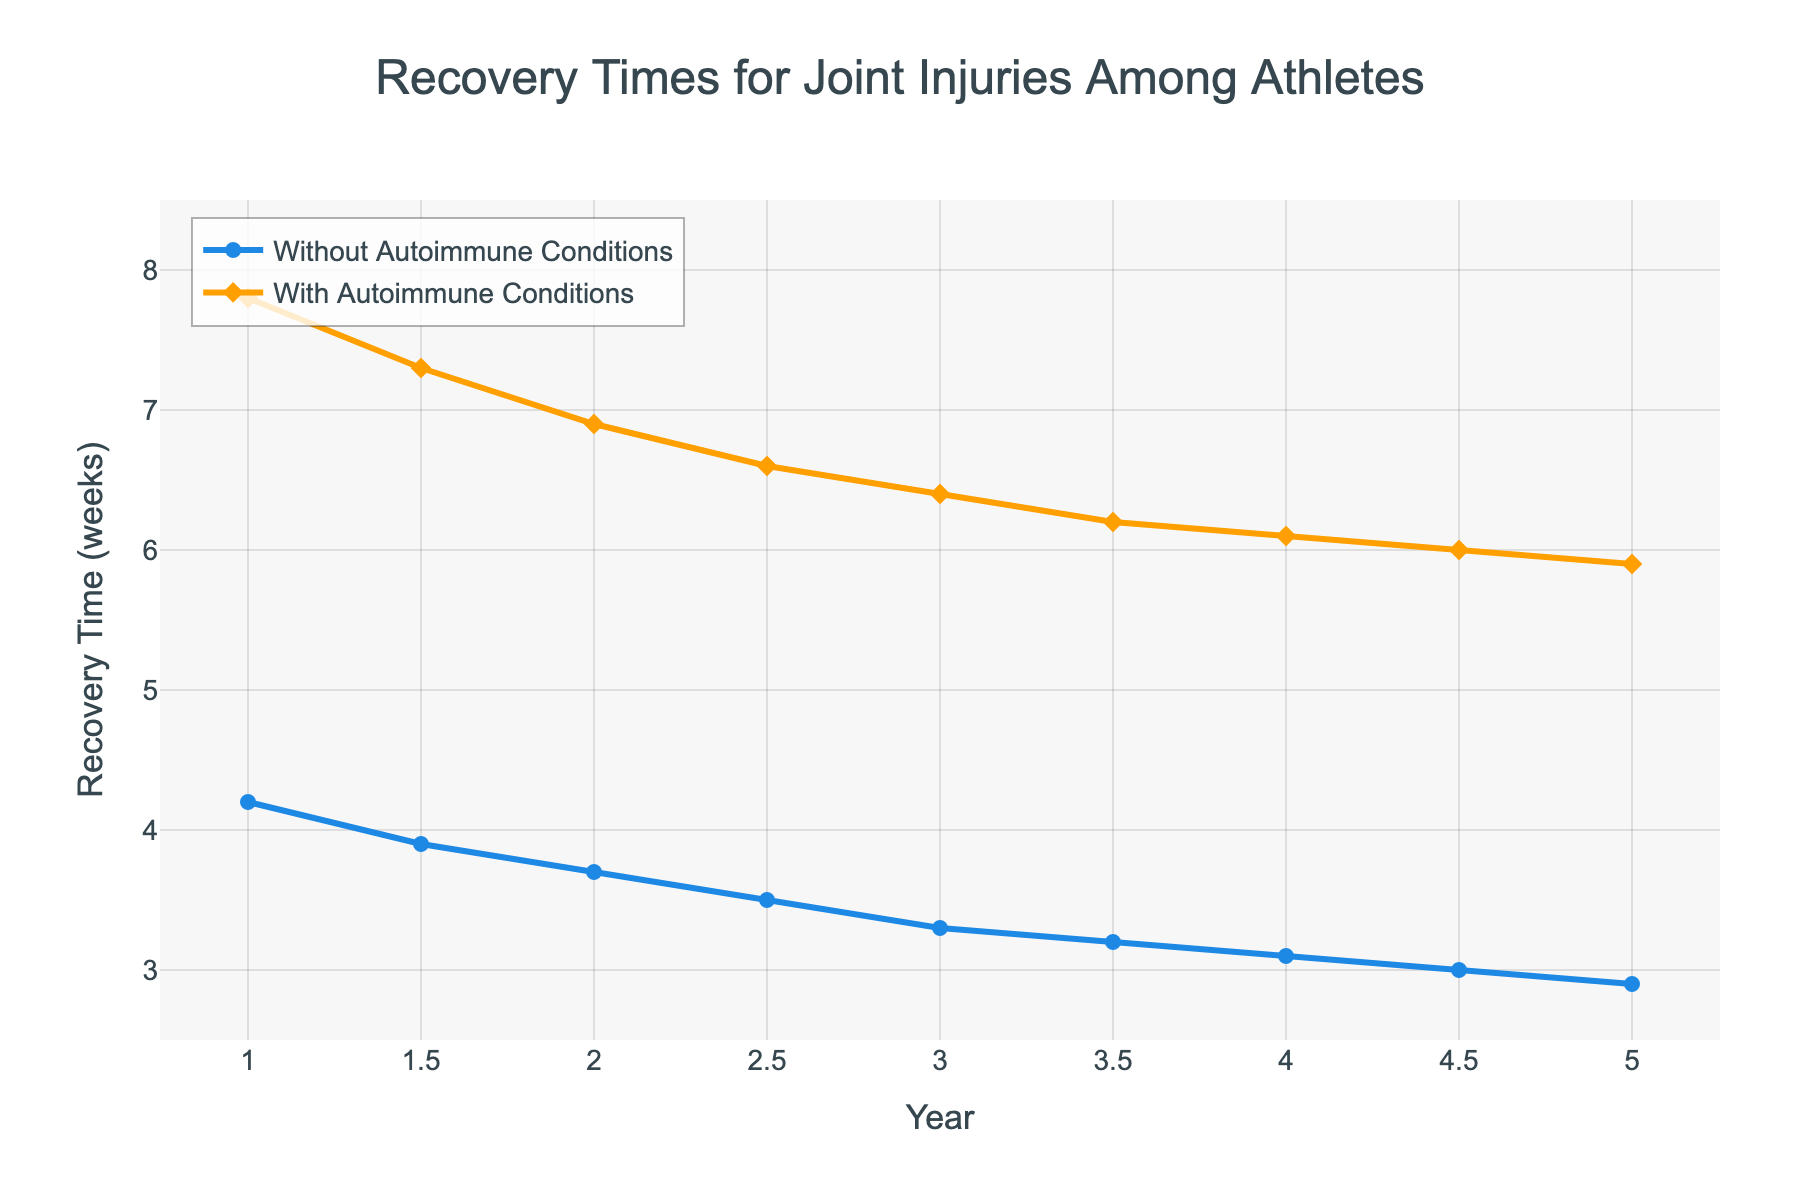What is the trend in recovery times over the 5-year period for athletes without autoimmune conditions? To identify the trend for athletes without autoimmune conditions, follow the blue line in the figure. Over the 5-year period, the recovery time decreases gradually from 4.2 weeks to 2.9 weeks.
Answer: Decreasing What is the difference in recovery times between the two groups in the first year? In the first year, the recovery time for athletes without autoimmune conditions is 4.2 weeks and 7.8 weeks for athletes with autoimmune conditions. The difference is calculated as 7.8 - 4.2.
Answer: 3.6 weeks How much faster do athletes without autoimmune conditions recover than athletes with autoimmune conditions in the third year? In the third year, the recovery time for athletes without autoimmune conditions is 3.3 weeks, while it is 6.4 weeks for those with autoimmune conditions. The difference is calculated as 6.4 - 3.3.
Answer: 3.1 weeks By how much did the recovery time improve for athletes with autoimmune conditions from the first to the fifth year? For athletes with autoimmune conditions, the recovery time in the first year is 7.8 weeks, and in the fifth year, it is 5.9 weeks. The improvement is calculated as 7.8 - 5.9.
Answer: 1.9 weeks At which year do the recovery times for both groups differ the least? To find the year with the least difference, compare the differences in each year by visually observing the distances between the two lines. In the fifth year, the difference is the smallest.
Answer: 5th year What is the average recovery time for athletes without autoimmune conditions over the 5-year period? Sum the recovery times for athletes without autoimmune conditions over the years: (4.2 + 3.9 + 3.7 + 3.5 + 3.3 + 3.2 + 3.1 + 3.0 + 2.9) and divide by the number of data points.  Questions for detailed arithmetic steps needed.
Answer: 3.4 weeks What is the average recovery time for athletes with autoimmune conditions in the last two years? Sum the recovery times in the fourth and fifth years (6.1 + 5.9) and divide by 2.
Answer: 6.0 weeks Which group shows a consistent decrease in recovery time over the years? By observing the trends of both lines in the figure, we can see that both lines decrease, but the one for athletes without autoimmune conditions decreases more consistently.
Answer: Athletes without autoimmune conditions In which year is the recovery time for athletes with autoimmune conditions closest to 6 weeks? Look at the yellow line and identify the year where the y-value is closest to 6 weeks. This occurs in the fifth year.
Answer: 5th year 